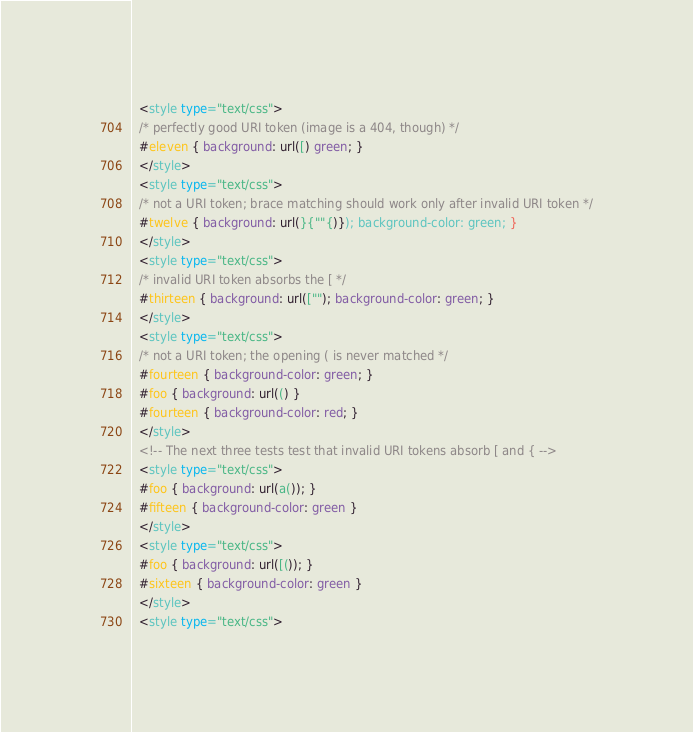<code> <loc_0><loc_0><loc_500><loc_500><_HTML_>  <style type="text/css">
  /* perfectly good URI token (image is a 404, though) */
  #eleven { background: url([) green; }
  </style>
  <style type="text/css">
  /* not a URI token; brace matching should work only after invalid URI token */
  #twelve { background: url(}{""{)}); background-color: green; }
  </style>
  <style type="text/css">
  /* invalid URI token absorbs the [ */
  #thirteen { background: url([""); background-color: green; }
  </style>
  <style type="text/css">
  /* not a URI token; the opening ( is never matched */
  #fourteen { background-color: green; }
  #foo { background: url(() }
  #fourteen { background-color: red; }
  </style>
  <!-- The next three tests test that invalid URI tokens absorb [ and { -->
  <style type="text/css">
  #foo { background: url(a()); }
  #fifteen { background-color: green }
  </style>
  <style type="text/css">
  #foo { background: url([()); }
  #sixteen { background-color: green }
  </style>
  <style type="text/css"></code> 